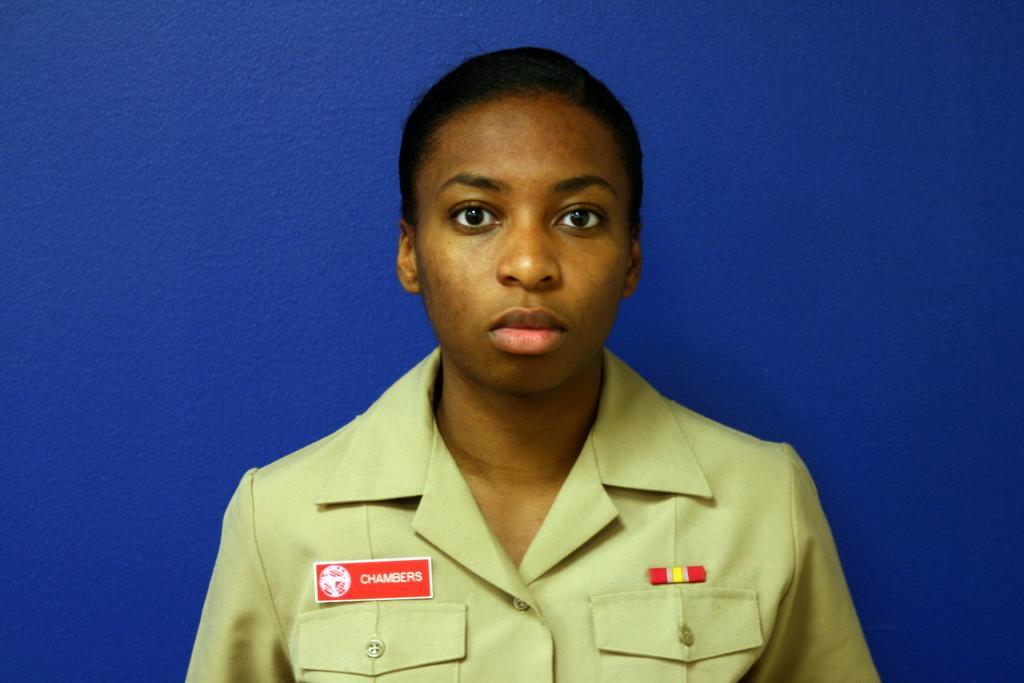Could you give a brief overview of what you see in this image? In this image, we can see a woman is watching. Here we can see a batch on her shirt. Background we can see blue surface. 